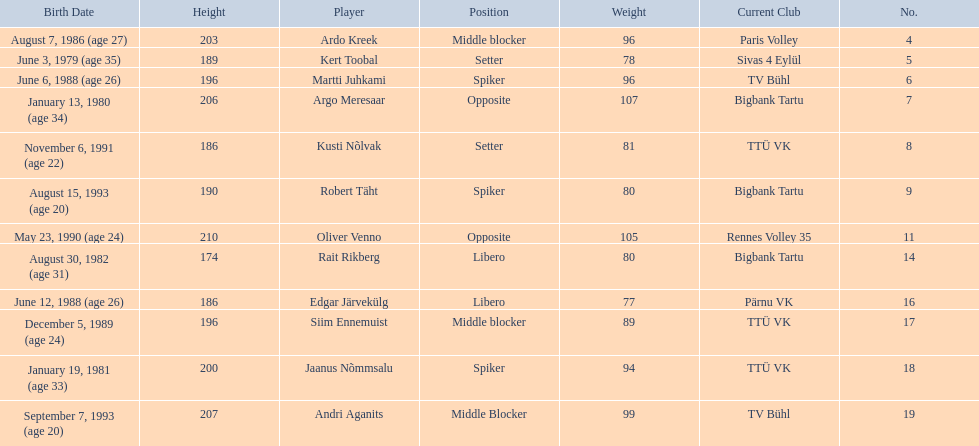What are the heights in cm of the men on the team? 203, 189, 196, 206, 186, 190, 210, 174, 186, 196, 200, 207. What is the tallest height of a team member? 210. Which player stands at 210? Oliver Venno. 